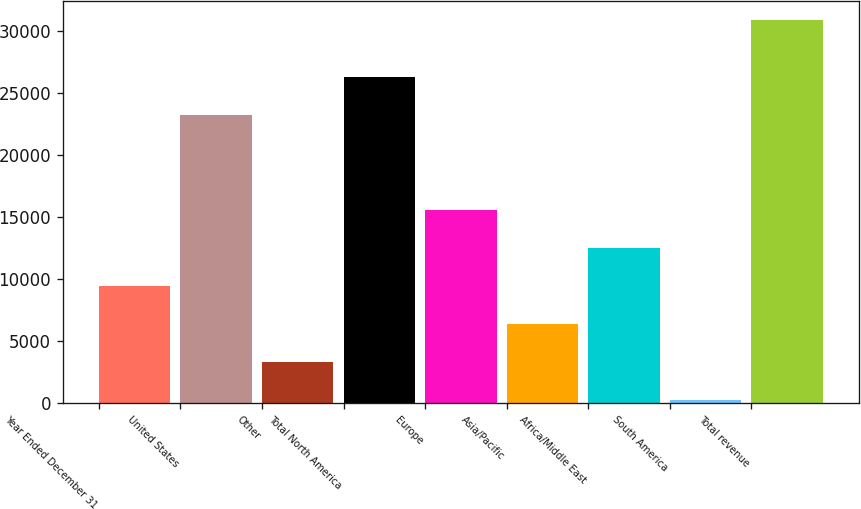<chart> <loc_0><loc_0><loc_500><loc_500><bar_chart><fcel>Year Ended December 31<fcel>United States<fcel>Other<fcel>Total North America<fcel>Europe<fcel>Asia/Pacific<fcel>Africa/Middle East<fcel>South America<fcel>Total revenue<nl><fcel>9448.1<fcel>23222<fcel>3332.7<fcel>26279.7<fcel>15563.5<fcel>6390.4<fcel>12505.8<fcel>275<fcel>30852<nl></chart> 